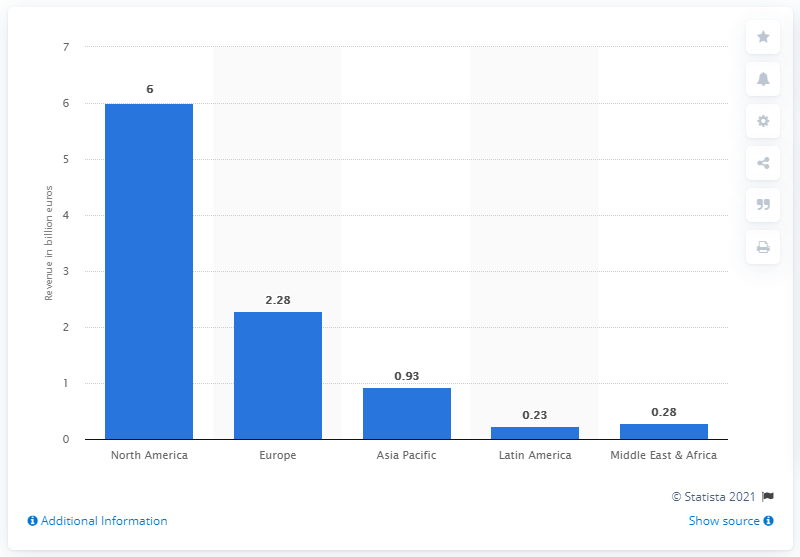Draw attention to some important aspects in this diagram. Publicis Groupe's revenue in Europe for the fiscal year 2020 was 2.28 billion. 